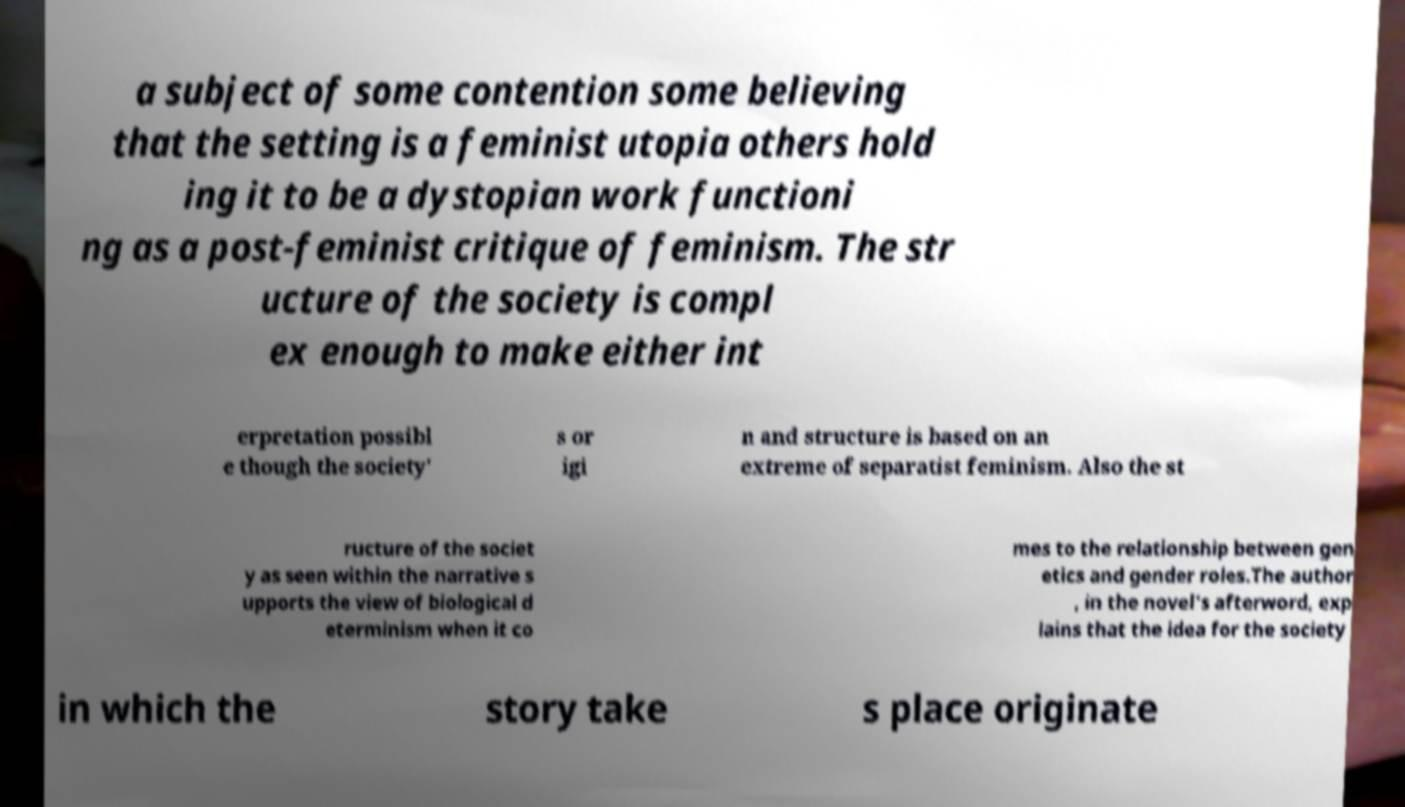For documentation purposes, I need the text within this image transcribed. Could you provide that? a subject of some contention some believing that the setting is a feminist utopia others hold ing it to be a dystopian work functioni ng as a post-feminist critique of feminism. The str ucture of the society is compl ex enough to make either int erpretation possibl e though the society' s or igi n and structure is based on an extreme of separatist feminism. Also the st ructure of the societ y as seen within the narrative s upports the view of biological d eterminism when it co mes to the relationship between gen etics and gender roles.The author , in the novel's afterword, exp lains that the idea for the society in which the story take s place originate 